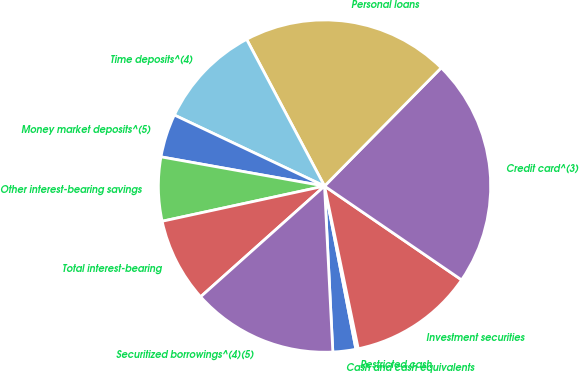Convert chart to OTSL. <chart><loc_0><loc_0><loc_500><loc_500><pie_chart><fcel>Cash and cash equivalents<fcel>Restricted cash<fcel>Investment securities<fcel>Credit card^(3)<fcel>Personal loans<fcel>Time deposits^(4)<fcel>Money market deposits^(5)<fcel>Other interest-bearing savings<fcel>Total interest-bearing<fcel>Securitized borrowings^(4)(5)<nl><fcel>2.23%<fcel>0.23%<fcel>12.19%<fcel>22.16%<fcel>20.16%<fcel>10.2%<fcel>4.22%<fcel>6.21%<fcel>8.21%<fcel>14.19%<nl></chart> 